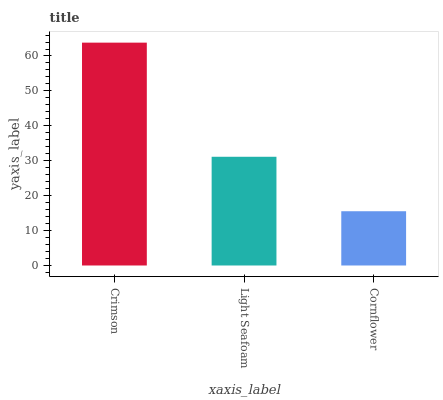Is Cornflower the minimum?
Answer yes or no. Yes. Is Crimson the maximum?
Answer yes or no. Yes. Is Light Seafoam the minimum?
Answer yes or no. No. Is Light Seafoam the maximum?
Answer yes or no. No. Is Crimson greater than Light Seafoam?
Answer yes or no. Yes. Is Light Seafoam less than Crimson?
Answer yes or no. Yes. Is Light Seafoam greater than Crimson?
Answer yes or no. No. Is Crimson less than Light Seafoam?
Answer yes or no. No. Is Light Seafoam the high median?
Answer yes or no. Yes. Is Light Seafoam the low median?
Answer yes or no. Yes. Is Crimson the high median?
Answer yes or no. No. Is Cornflower the low median?
Answer yes or no. No. 